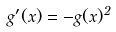Convert formula to latex. <formula><loc_0><loc_0><loc_500><loc_500>g ^ { \prime } ( x ) = - g ( x ) ^ { 2 }</formula> 